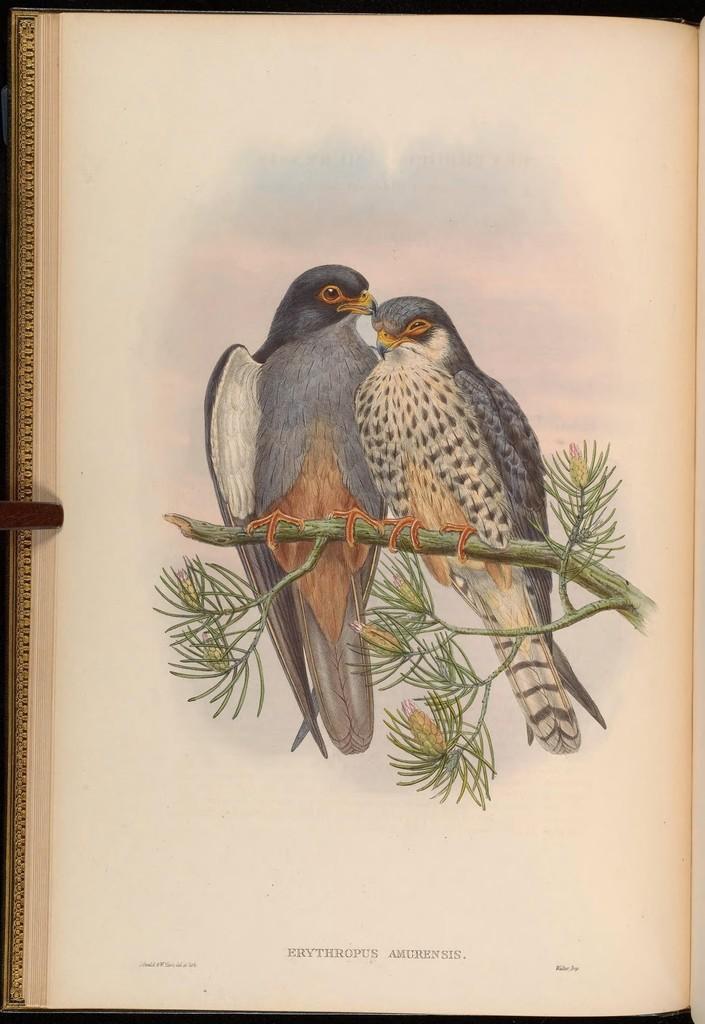Could you give a brief overview of what you see in this image? In this image we can see page of the book. There is a drawing of two birds sitting on the branch of the tree. There is some text at the bottom of the book. 